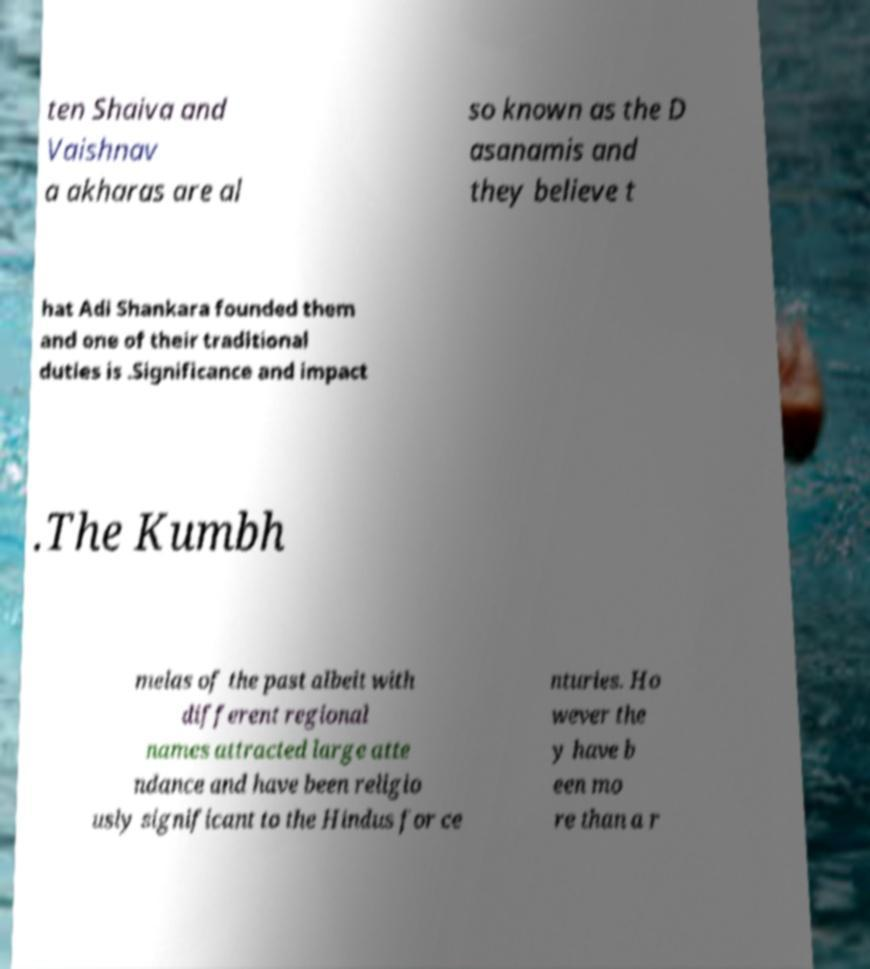I need the written content from this picture converted into text. Can you do that? ten Shaiva and Vaishnav a akharas are al so known as the D asanamis and they believe t hat Adi Shankara founded them and one of their traditional duties is .Significance and impact .The Kumbh melas of the past albeit with different regional names attracted large atte ndance and have been religio usly significant to the Hindus for ce nturies. Ho wever the y have b een mo re than a r 